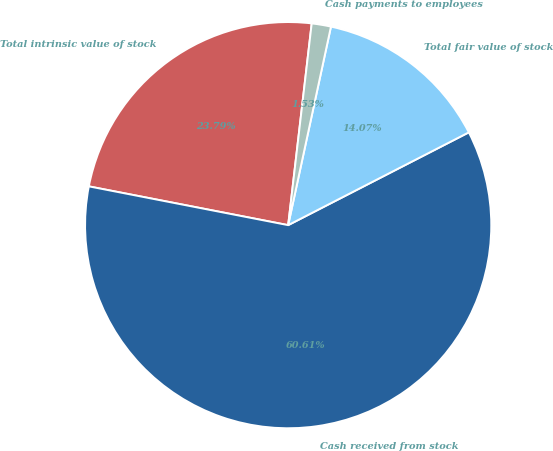Convert chart to OTSL. <chart><loc_0><loc_0><loc_500><loc_500><pie_chart><fcel>Total intrinsic value of stock<fcel>Cash received from stock<fcel>Total fair value of stock<fcel>Cash payments to employees<nl><fcel>23.79%<fcel>60.61%<fcel>14.07%<fcel>1.53%<nl></chart> 